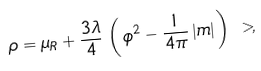Convert formula to latex. <formula><loc_0><loc_0><loc_500><loc_500>\rho & = \mu _ { R } + \frac { 3 \lambda } { 4 } \, \left ( \, \phi ^ { 2 } - \frac { 1 } { 4 \pi } \, | m | \, \right ) \ > ,</formula> 